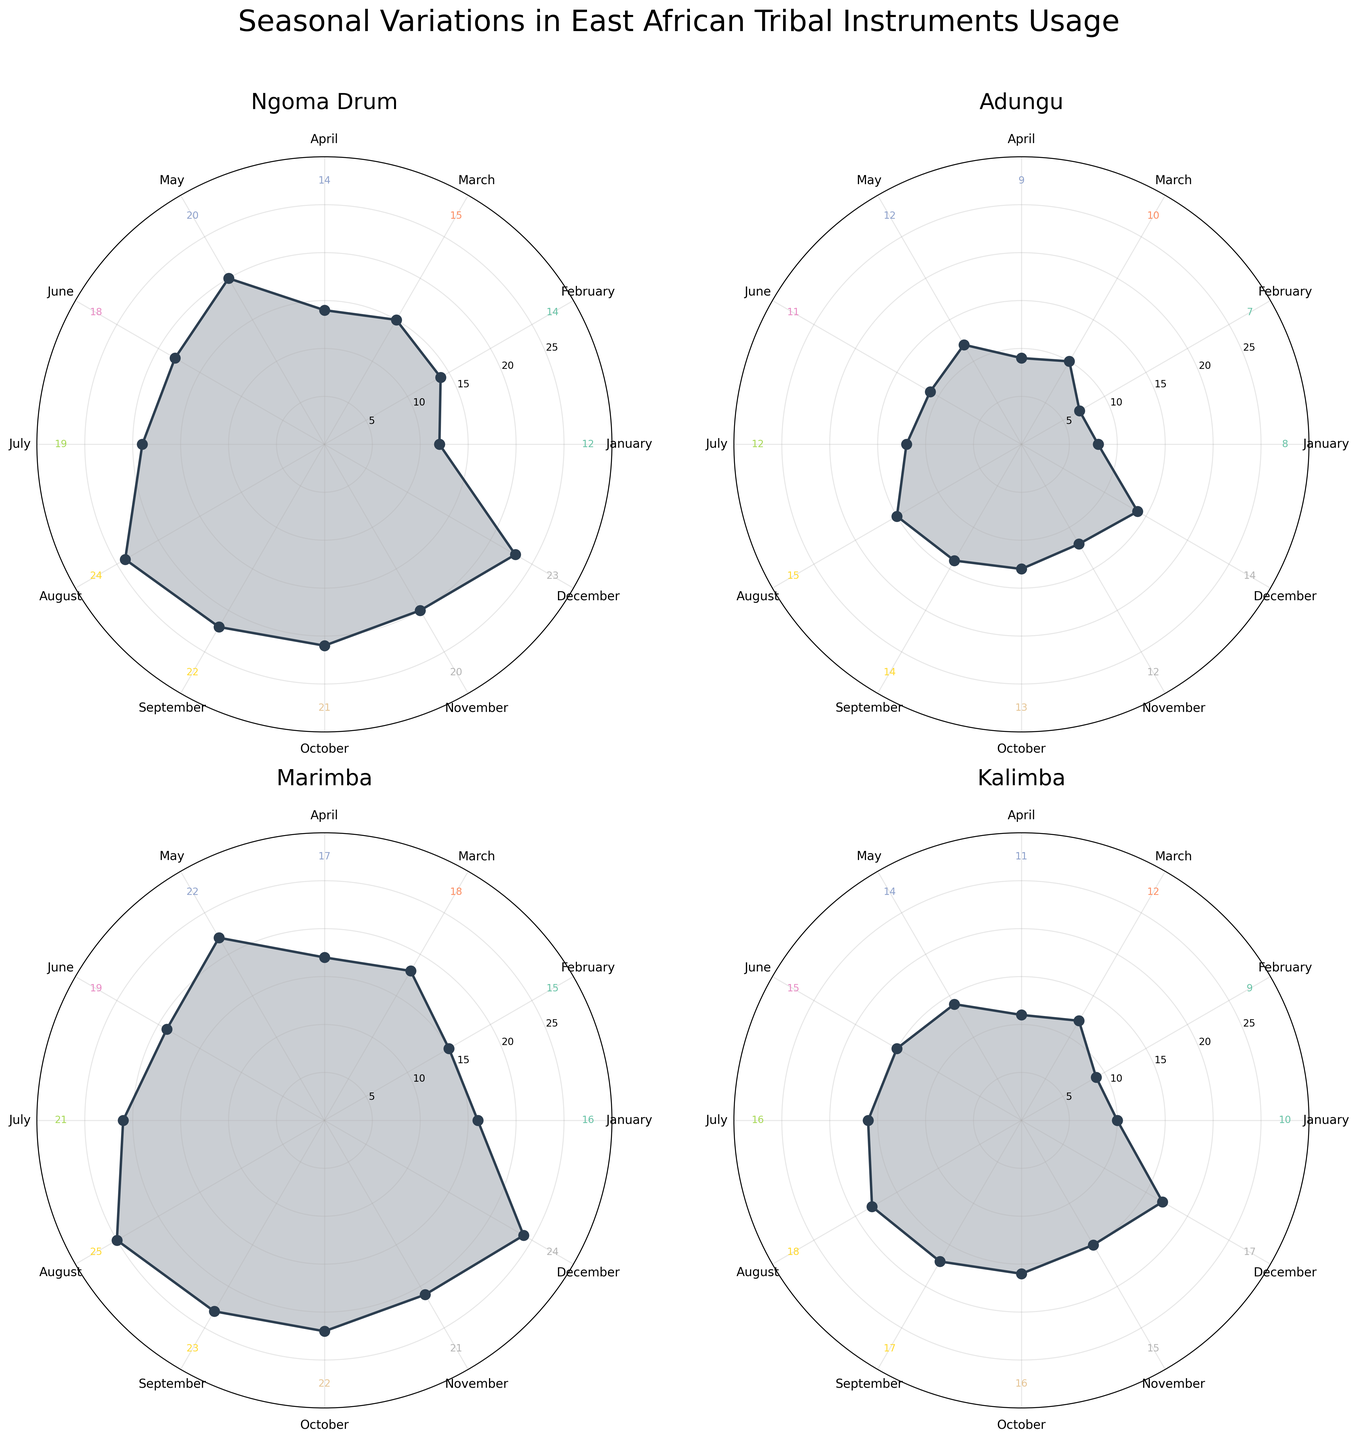How many instruments are being tracked in the figure? There are four subplots in total, each representing a different instrument.
Answer: Four Which instrument has its highest usage frequency in August? By examining each subplot, note that only the Ngoma Drum, Adungu, Marimba, and Kalimba have their highest peaks in August.
Answer: All of them What is the title of the figure? The title is displayed at the top of the figure, specifying the context and scope.
Answer: Seasonal Variations in East African Tribal Instruments Usage In which month does the Ngoma Drum have its lowest usage frequency? Check the subplot for the Ngoma Drum and identify the month with the smallest value.
Answer: January What is the total usage frequency of the Kalimba in the summer months (June, July, August)? Sum the usage frequencies in June (15), July (16), and August (18) for the Kalimba.
Answer: 49 Which instrument shows the most consistent usage frequency across all months? Look for the subplot with the least amount of variation in usage frequencies.
Answer: Adungu Between May and September, which month has the highest usage for the Marimba? Compare the numbers given on the Marimba subplot for these months: May (22), June (19), July (21), August (25), September (23).
Answer: August Which month has the highest overall usage across all instruments? Sum the usage frequencies of all instruments for each month and identify the month with the highest total. August has the highest total (24+15+25+18 = 82).
Answer: August How does the usage frequency of the Ngoma Drum in January compare to its usage frequency in December? Look at the values in the Ngoma Drum subplot for January (12) and December (23).
Answer: Lower in January What is the average usage frequency of Adungu for the first quarter (Jan-Mar)? Find the average by summing the usage frequencies for Adungu in January (8), February (7), and March (10), then divide by 3.
Answer: 8.33 